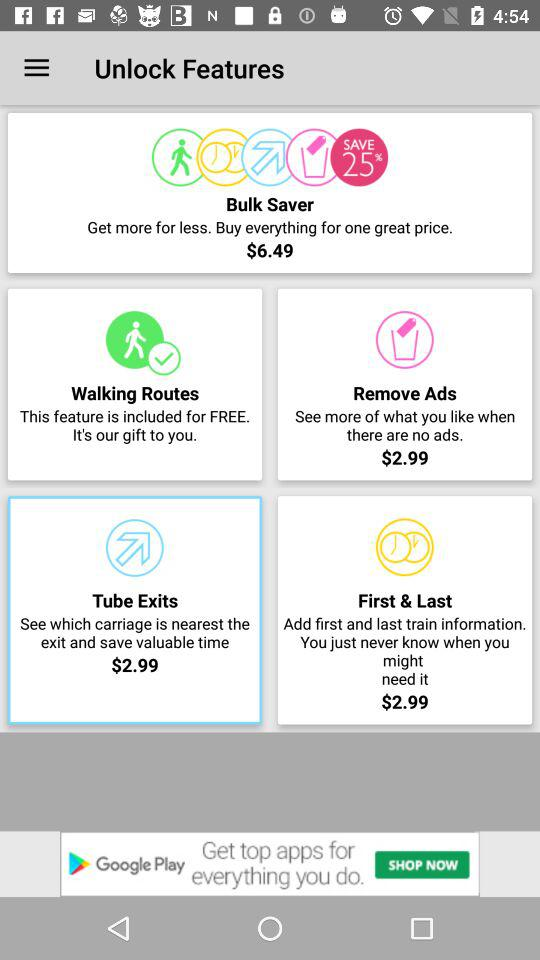What is the offer to save?
When the provided information is insufficient, respond with <no answer>. <no answer> 